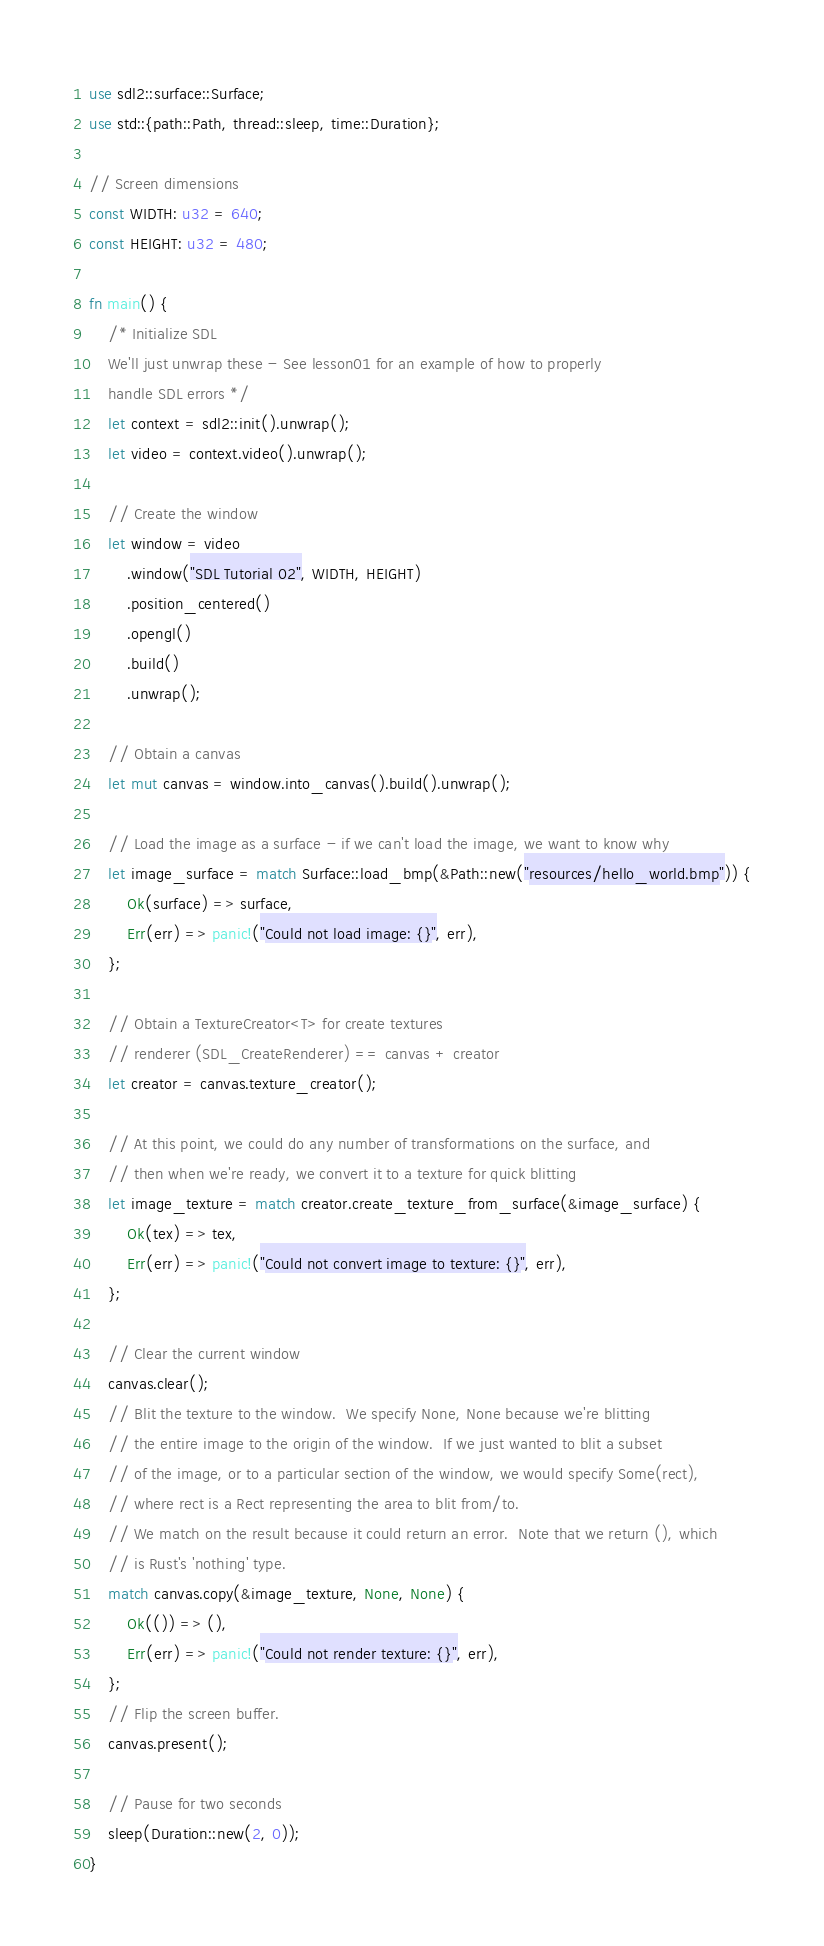Convert code to text. <code><loc_0><loc_0><loc_500><loc_500><_Rust_>use sdl2::surface::Surface;
use std::{path::Path, thread::sleep, time::Duration};

// Screen dimensions
const WIDTH: u32 = 640;
const HEIGHT: u32 = 480;

fn main() {
    /* Initialize SDL
    We'll just unwrap these - See lesson01 for an example of how to properly
    handle SDL errors */
    let context = sdl2::init().unwrap();
    let video = context.video().unwrap();

    // Create the window
    let window = video
        .window("SDL Tutorial 02", WIDTH, HEIGHT)
        .position_centered()
        .opengl()
        .build()
        .unwrap();

    // Obtain a canvas
    let mut canvas = window.into_canvas().build().unwrap();

    // Load the image as a surface - if we can't load the image, we want to know why
    let image_surface = match Surface::load_bmp(&Path::new("resources/hello_world.bmp")) {
        Ok(surface) => surface,
        Err(err) => panic!("Could not load image: {}", err),
    };

    // Obtain a TextureCreator<T> for create textures
    // renderer (SDL_CreateRenderer) == canvas + creator
    let creator = canvas.texture_creator();

    // At this point, we could do any number of transformations on the surface, and
    // then when we're ready, we convert it to a texture for quick blitting
    let image_texture = match creator.create_texture_from_surface(&image_surface) {
        Ok(tex) => tex,
        Err(err) => panic!("Could not convert image to texture: {}", err),
    };

    // Clear the current window
    canvas.clear();
    // Blit the texture to the window.  We specify None, None because we're blitting
    // the entire image to the origin of the window.  If we just wanted to blit a subset
    // of the image, or to a particular section of the window, we would specify Some(rect),
    // where rect is a Rect representing the area to blit from/to.
    // We match on the result because it could return an error.  Note that we return (), which
    // is Rust's 'nothing' type.
    match canvas.copy(&image_texture, None, None) {
        Ok(()) => (),
        Err(err) => panic!("Could not render texture: {}", err),
    };
    // Flip the screen buffer.
    canvas.present();

    // Pause for two seconds
    sleep(Duration::new(2, 0));
}
</code> 